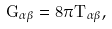Convert formula to latex. <formula><loc_0><loc_0><loc_500><loc_500>G _ { \alpha \beta } = 8 \pi T _ { \alpha \beta } ,</formula> 